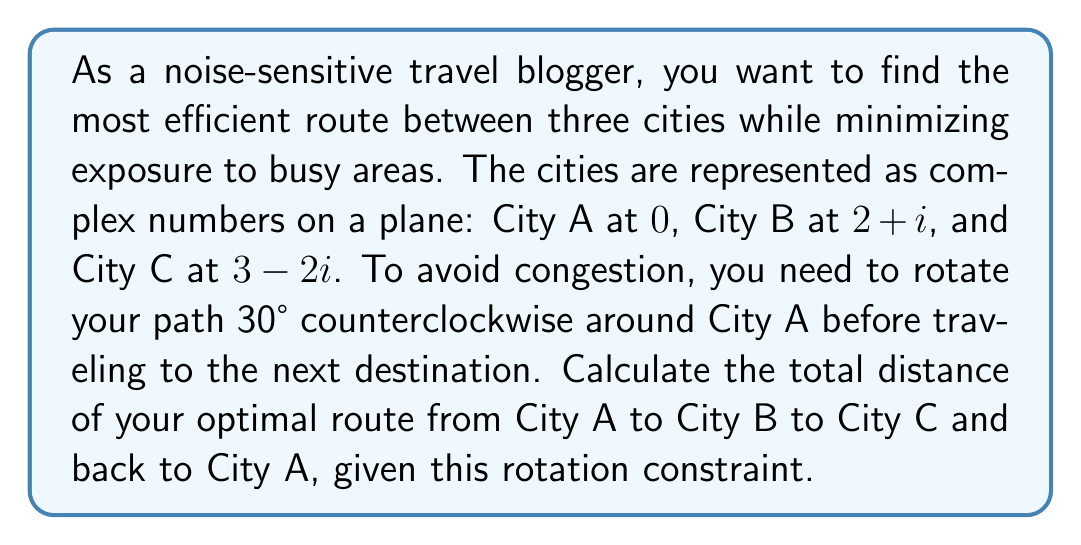Help me with this question. Let's approach this step-by-step:

1) First, we need to understand the rotation. A 30° counterclockwise rotation is represented by multiplication with the complex number $\cos 30° + i \sin 30° = \frac{\sqrt{3}}{2} + \frac{1}{2}i$.

2) Let's calculate each leg of the journey:

   A to B: $(2+i) \cdot (\frac{\sqrt{3}}{2} + \frac{1}{2}i) = (\sqrt{3} - \frac{1}{2}) + (\frac{\sqrt{3}}{2} + 1)i$

   B to C: $((3-2i) - (2+i)) \cdot (\frac{\sqrt{3}}{2} + \frac{1}{2}i) = (1-3i) \cdot (\frac{\sqrt{3}}{2} + \frac{1}{2}i) = (\frac{\sqrt{3}}{2} + \frac{3}{2}) + (-\frac{3\sqrt{3}}{2} + \frac{1}{2})i$

   C to A: $(0 - (3-2i)) \cdot (\frac{\sqrt{3}}{2} + \frac{1}{2}i) = (-3+2i) \cdot (\frac{\sqrt{3}}{2} + \frac{1}{2}i) = (-\frac{3\sqrt{3}}{2} - 1) + (-\frac{3}{2} + \sqrt{3})i$

3) Now, we need to calculate the magnitude of each of these complex numbers to get the distances:

   A to B: $\sqrt{(\sqrt{3} - \frac{1}{2})^2 + (\frac{\sqrt{3}}{2} + 1)^2} = \sqrt{4 - \sqrt{3} + \frac{1}{4} + \frac{3}{4} + \sqrt{3} + 1} = \sqrt{6} \approx 2.45$

   B to C: $\sqrt{(\frac{\sqrt{3}}{2} + \frac{3}{2})^2 + (-\frac{3\sqrt{3}}{2} + \frac{1}{2})^2} = \sqrt{\frac{3}{4} + \frac{3\sqrt{3}}{2} + \frac{9}{4} + \frac{27}{4} - \frac{3\sqrt{3}}{2} + \frac{1}{4}} = \sqrt{\frac{40}{4}} = \sqrt{10} \approx 3.16$

   C to A: $\sqrt{(-\frac{3\sqrt{3}}{2} - 1)^2 + (-\frac{3}{2} + \sqrt{3})^2} = \sqrt{\frac{27}{4} + 3\sqrt{3} + 1 + \frac{9}{4} - 3\sqrt{3} + 3} = \sqrt{13} \approx 3.61$

4) The total distance is the sum of these three distances:

   Total distance = $\sqrt{6} + \sqrt{10} + \sqrt{13} \approx 2.45 + 3.16 + 3.61 = 9.22$
Answer: The total distance of the optimal route is $\sqrt{6} + \sqrt{10} + \sqrt{13} \approx 9.22$ units. 